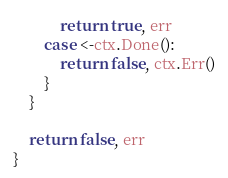<code> <loc_0><loc_0><loc_500><loc_500><_Go_>			return true, err
		case <-ctx.Done():
			return false, ctx.Err()
		}
	}

	return false, err
}
</code> 